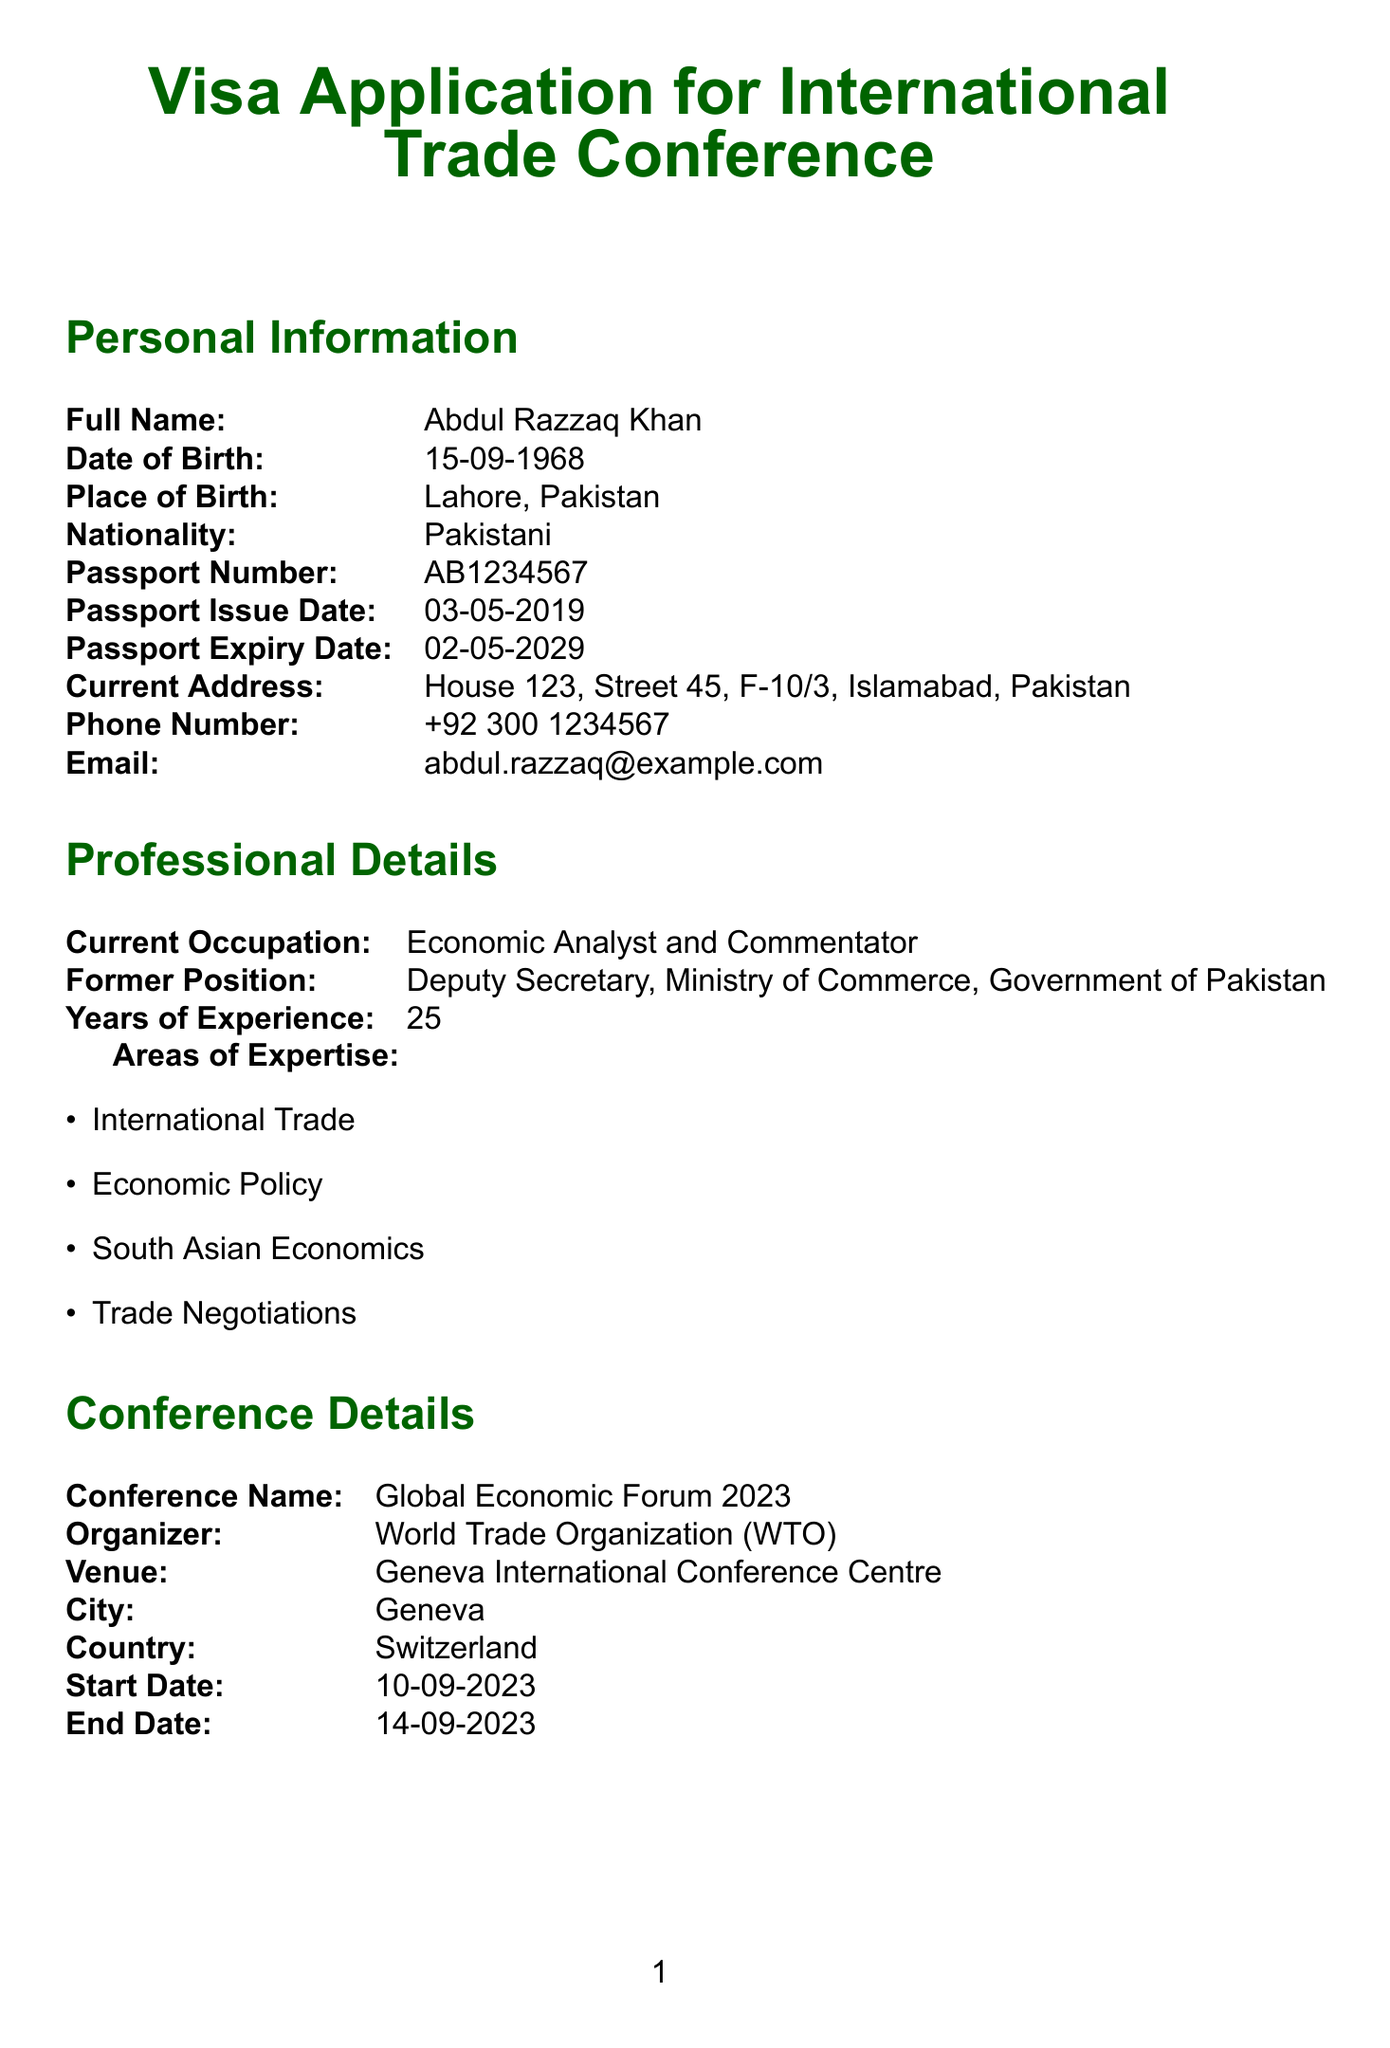what is the full name of the applicant? The full name is listed under Personal Information in the document.
Answer: Abdul Razzaq Khan what is the date of birth of the applicant? The date of birth is provided in the Personal Information section of the document.
Answer: 15-09-1968 where is the conference being held? The venue is specified in the Conference Details section.
Answer: Geneva International Conference Centre what is the purpose of the visit? The purpose of the visit is stated under Travel Information in the document.
Answer: To attend and speak at the Global Economic Forum 2023 how long is the conference? The start and end dates of the conference are mentioned in the document.
Answer: 5 days what is the funding source for the visit? The source of funding is indicated in the Travel Information section.
Answer: Self-funded who is the organizer of the conference? The organizer's name is included in the Conference Details part of the document.
Answer: World Trade Organization (WTO) how many years of experience does the applicant have? The total years of experience is mentioned in the Professional Details section.
Answer: 25 years 